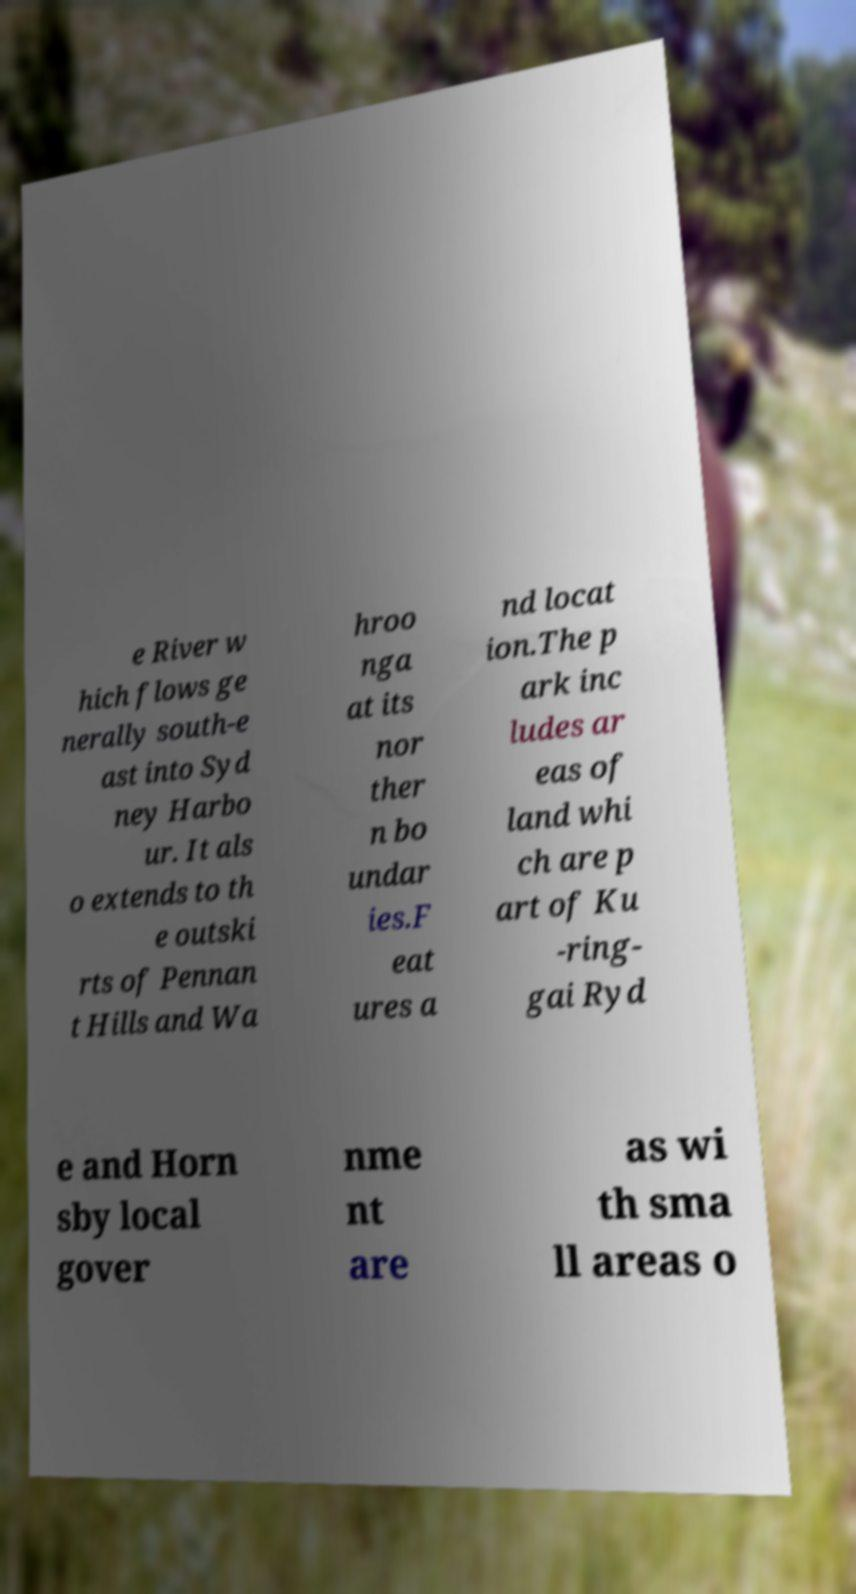For documentation purposes, I need the text within this image transcribed. Could you provide that? e River w hich flows ge nerally south-e ast into Syd ney Harbo ur. It als o extends to th e outski rts of Pennan t Hills and Wa hroo nga at its nor ther n bo undar ies.F eat ures a nd locat ion.The p ark inc ludes ar eas of land whi ch are p art of Ku -ring- gai Ryd e and Horn sby local gover nme nt are as wi th sma ll areas o 